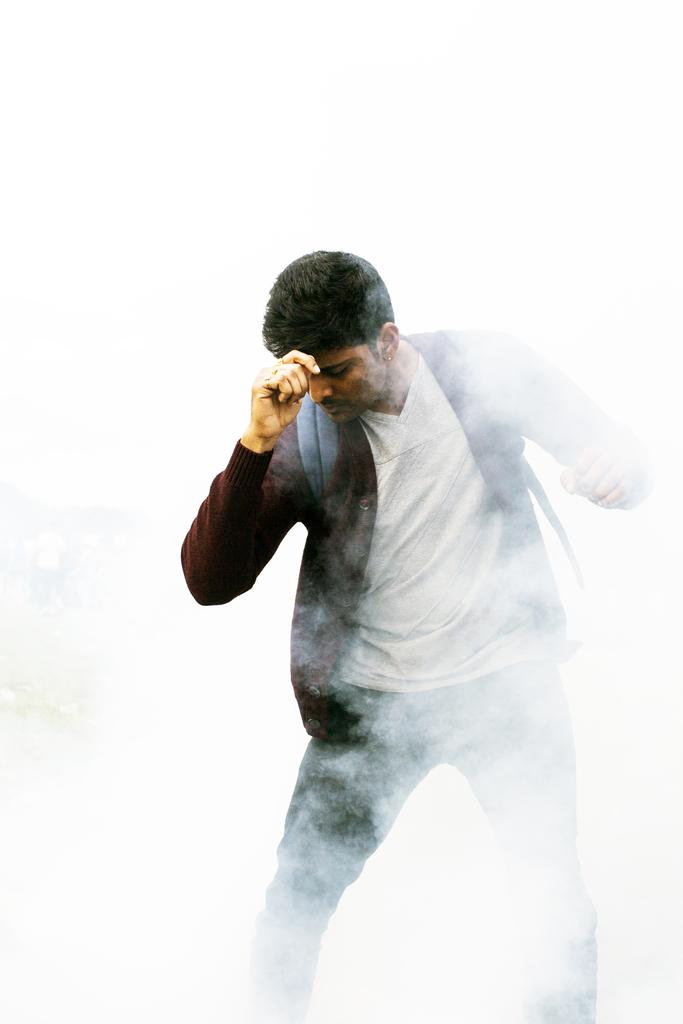What is present in the image? There is a person in the image. What is the person wearing? The person is wearing a bag. What else can be seen in the image? There is smoke visible in the image. Is the person's sister also present in the image? There is no mention of a sister in the image, so we cannot determine if they are present or not. 